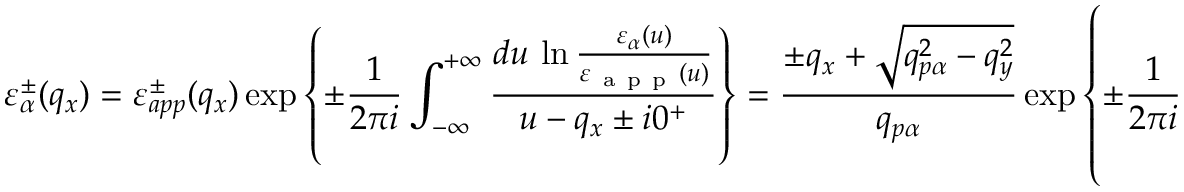<formula> <loc_0><loc_0><loc_500><loc_500>\varepsilon _ { \alpha } ^ { \pm } ( { { q } _ { x } } ) = \varepsilon _ { a p p } ^ { \pm } ( { { q } _ { x } } ) \exp \left \{ \pm \frac { 1 } { 2 \pi i } \int _ { - \infty } ^ { + \infty } { \frac { d u \, \ln \frac { { { \varepsilon } _ { \alpha } } ( u ) } { { { \varepsilon } _ { a p p } } ( u ) } } { u - { { q } _ { x } } \pm i { { 0 } ^ { + } } } } \right \} = \frac { \pm { { q } _ { x } } + \sqrt { q _ { p \alpha } ^ { 2 } - q _ { y } ^ { 2 } } } { { { q } _ { p \alpha } } } \exp \left \{ \pm \frac { 1 } { 2 \pi i } \int _ { - \infty } ^ { + \infty } { \frac { d u \, \ln \left [ 1 + \sqrt { \frac { { { u } ^ { 2 } } + q _ { y } ^ { 2 } } { q _ { p \alpha } ^ { 2 } } } \right ] } { u - { { q } _ { x } } \pm i { { 0 } ^ { + } } } } \right \} ,</formula> 